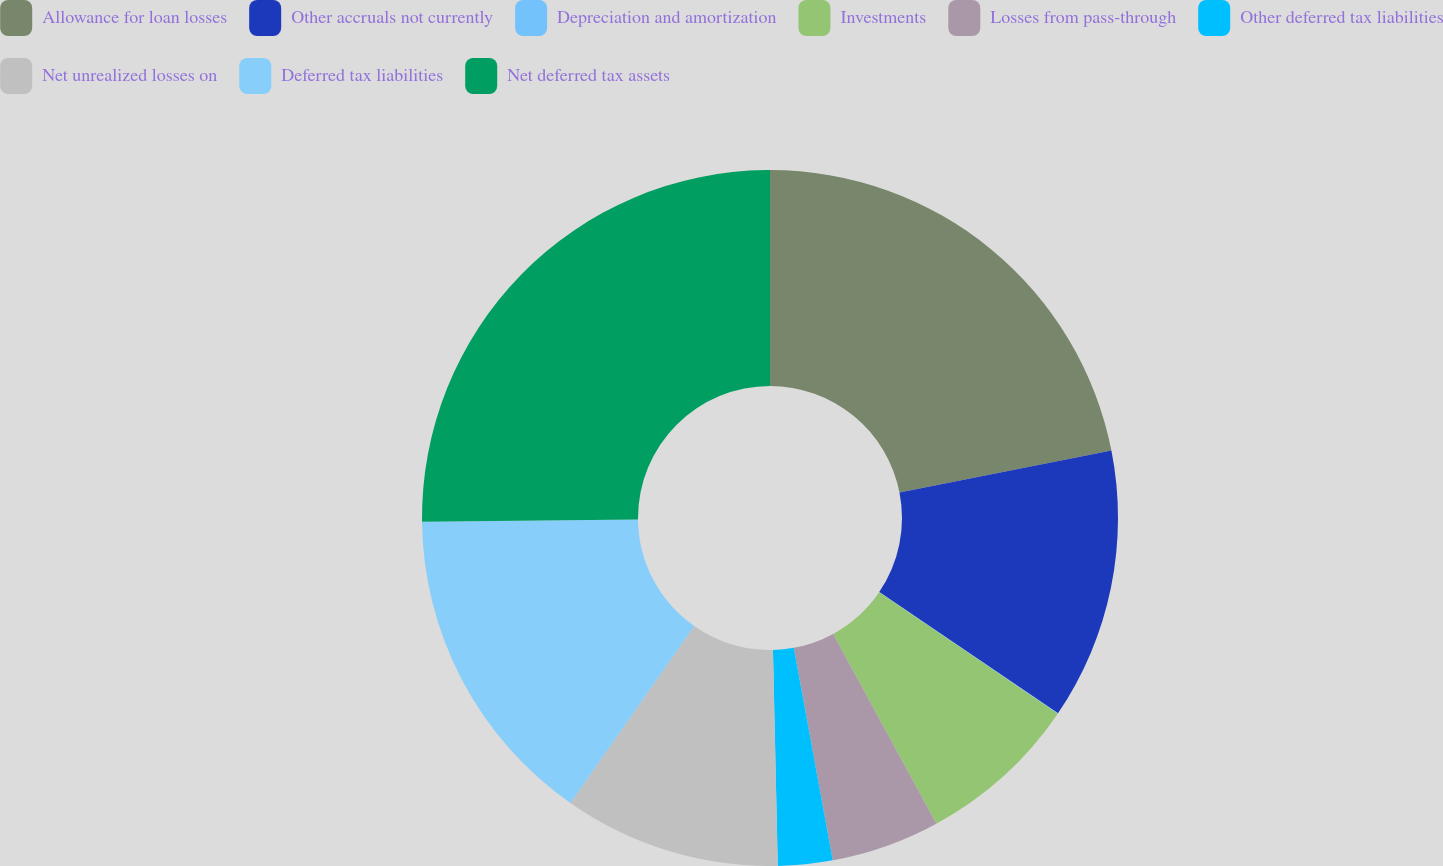Convert chart. <chart><loc_0><loc_0><loc_500><loc_500><pie_chart><fcel>Allowance for loan losses<fcel>Other accruals not currently<fcel>Depreciation and amortization<fcel>Investments<fcel>Losses from pass-through<fcel>Other deferred tax liabilities<fcel>Net unrealized losses on<fcel>Deferred tax liabilities<fcel>Net deferred tax assets<nl><fcel>21.9%<fcel>12.59%<fcel>0.02%<fcel>7.56%<fcel>5.05%<fcel>2.53%<fcel>10.08%<fcel>15.11%<fcel>25.17%<nl></chart> 